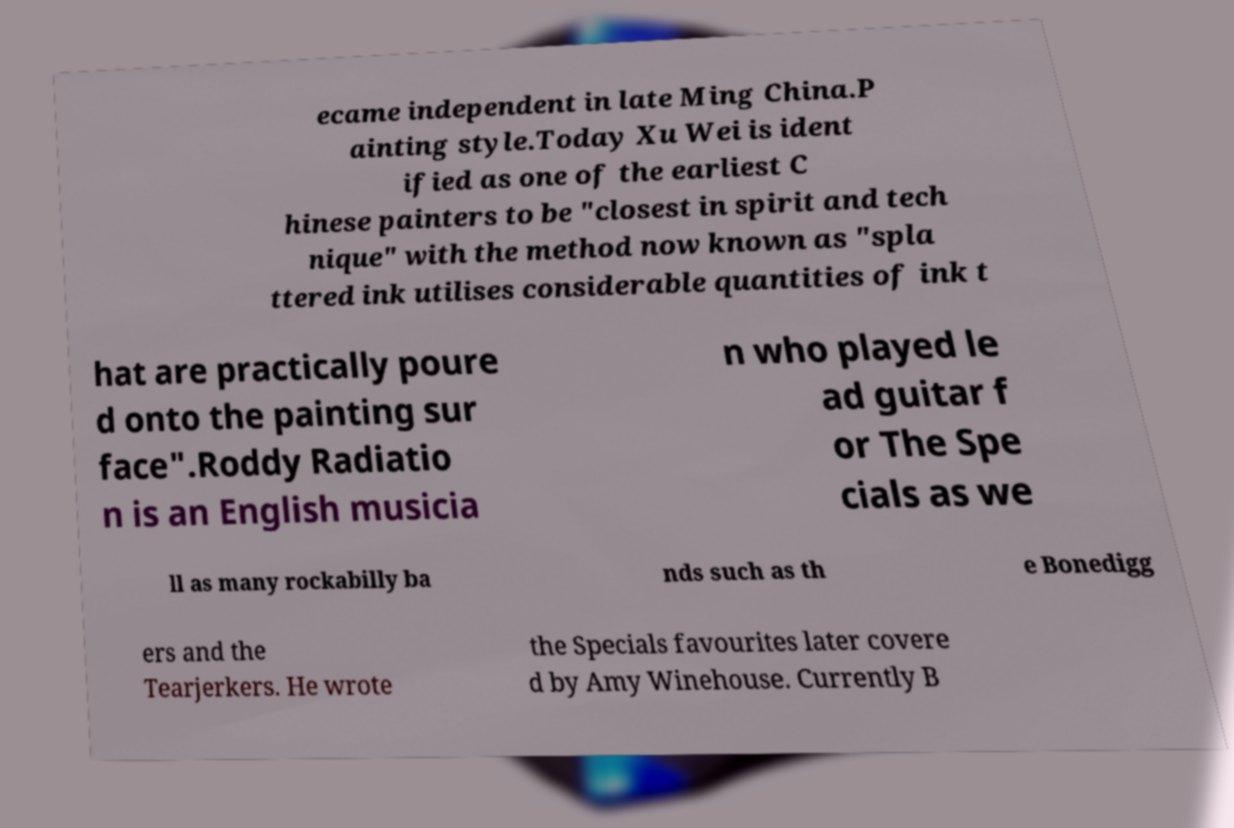Can you read and provide the text displayed in the image?This photo seems to have some interesting text. Can you extract and type it out for me? ecame independent in late Ming China.P ainting style.Today Xu Wei is ident ified as one of the earliest C hinese painters to be "closest in spirit and tech nique" with the method now known as "spla ttered ink utilises considerable quantities of ink t hat are practically poure d onto the painting sur face".Roddy Radiatio n is an English musicia n who played le ad guitar f or The Spe cials as we ll as many rockabilly ba nds such as th e Bonedigg ers and the Tearjerkers. He wrote the Specials favourites later covere d by Amy Winehouse. Currently B 